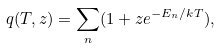Convert formula to latex. <formula><loc_0><loc_0><loc_500><loc_500>q ( T , z ) = \sum _ { n } ( 1 + z e ^ { - E _ { n } / k T } ) ,</formula> 